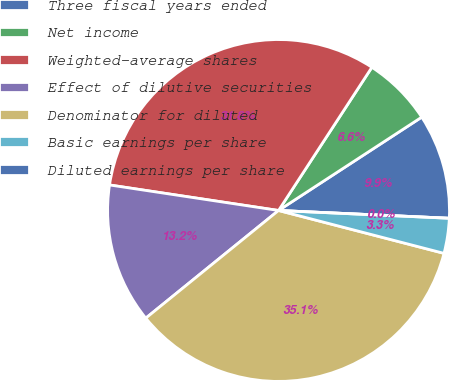Convert chart to OTSL. <chart><loc_0><loc_0><loc_500><loc_500><pie_chart><fcel>Three fiscal years ended<fcel>Net income<fcel>Weighted-average shares<fcel>Effect of dilutive securities<fcel>Denominator for diluted<fcel>Basic earnings per share<fcel>Diluted earnings per share<nl><fcel>9.92%<fcel>6.61%<fcel>31.81%<fcel>13.23%<fcel>35.12%<fcel>3.31%<fcel>0.0%<nl></chart> 